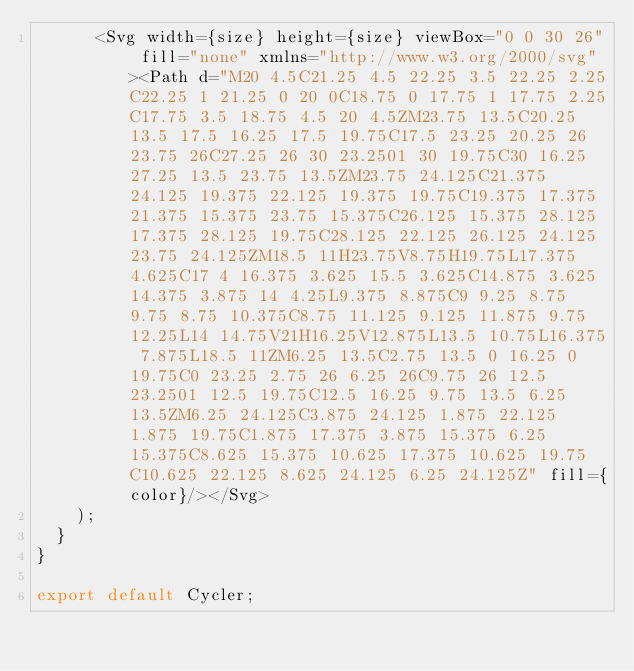Convert code to text. <code><loc_0><loc_0><loc_500><loc_500><_JavaScript_>      <Svg width={size} height={size} viewBox="0 0 30 26" fill="none" xmlns="http://www.w3.org/2000/svg"><Path d="M20 4.5C21.25 4.5 22.25 3.5 22.25 2.25C22.25 1 21.25 0 20 0C18.75 0 17.75 1 17.75 2.25C17.75 3.5 18.75 4.5 20 4.5ZM23.75 13.5C20.25 13.5 17.5 16.25 17.5 19.75C17.5 23.25 20.25 26 23.75 26C27.25 26 30 23.2501 30 19.75C30 16.25 27.25 13.5 23.75 13.5ZM23.75 24.125C21.375 24.125 19.375 22.125 19.375 19.75C19.375 17.375 21.375 15.375 23.75 15.375C26.125 15.375 28.125 17.375 28.125 19.75C28.125 22.125 26.125 24.125 23.75 24.125ZM18.5 11H23.75V8.75H19.75L17.375 4.625C17 4 16.375 3.625 15.5 3.625C14.875 3.625 14.375 3.875 14 4.25L9.375 8.875C9 9.25 8.75 9.75 8.75 10.375C8.75 11.125 9.125 11.875 9.75 12.25L14 14.75V21H16.25V12.875L13.5 10.75L16.375 7.875L18.5 11ZM6.25 13.5C2.75 13.5 0 16.25 0 19.75C0 23.25 2.75 26 6.25 26C9.75 26 12.5 23.2501 12.5 19.75C12.5 16.25 9.75 13.5 6.25 13.5ZM6.25 24.125C3.875 24.125 1.875 22.125 1.875 19.75C1.875 17.375 3.875 15.375 6.25 15.375C8.625 15.375 10.625 17.375 10.625 19.75C10.625 22.125 8.625 24.125 6.25 24.125Z" fill={color}/></Svg>
    );
  }
}

export default Cycler;
</code> 